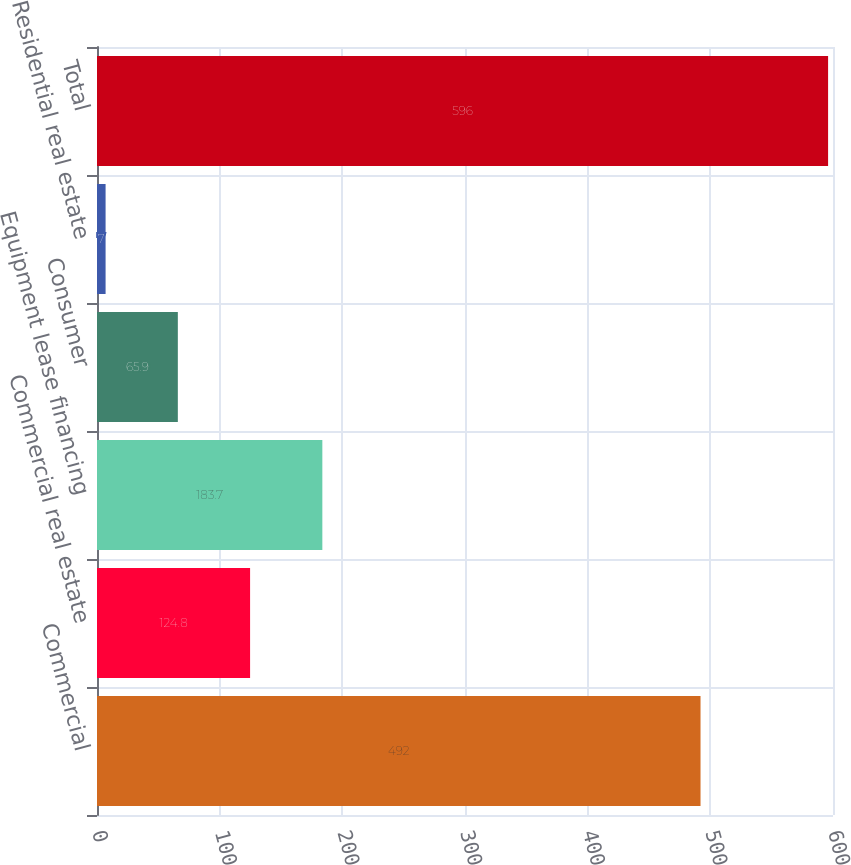Convert chart to OTSL. <chart><loc_0><loc_0><loc_500><loc_500><bar_chart><fcel>Commercial<fcel>Commercial real estate<fcel>Equipment lease financing<fcel>Consumer<fcel>Residential real estate<fcel>Total<nl><fcel>492<fcel>124.8<fcel>183.7<fcel>65.9<fcel>7<fcel>596<nl></chart> 